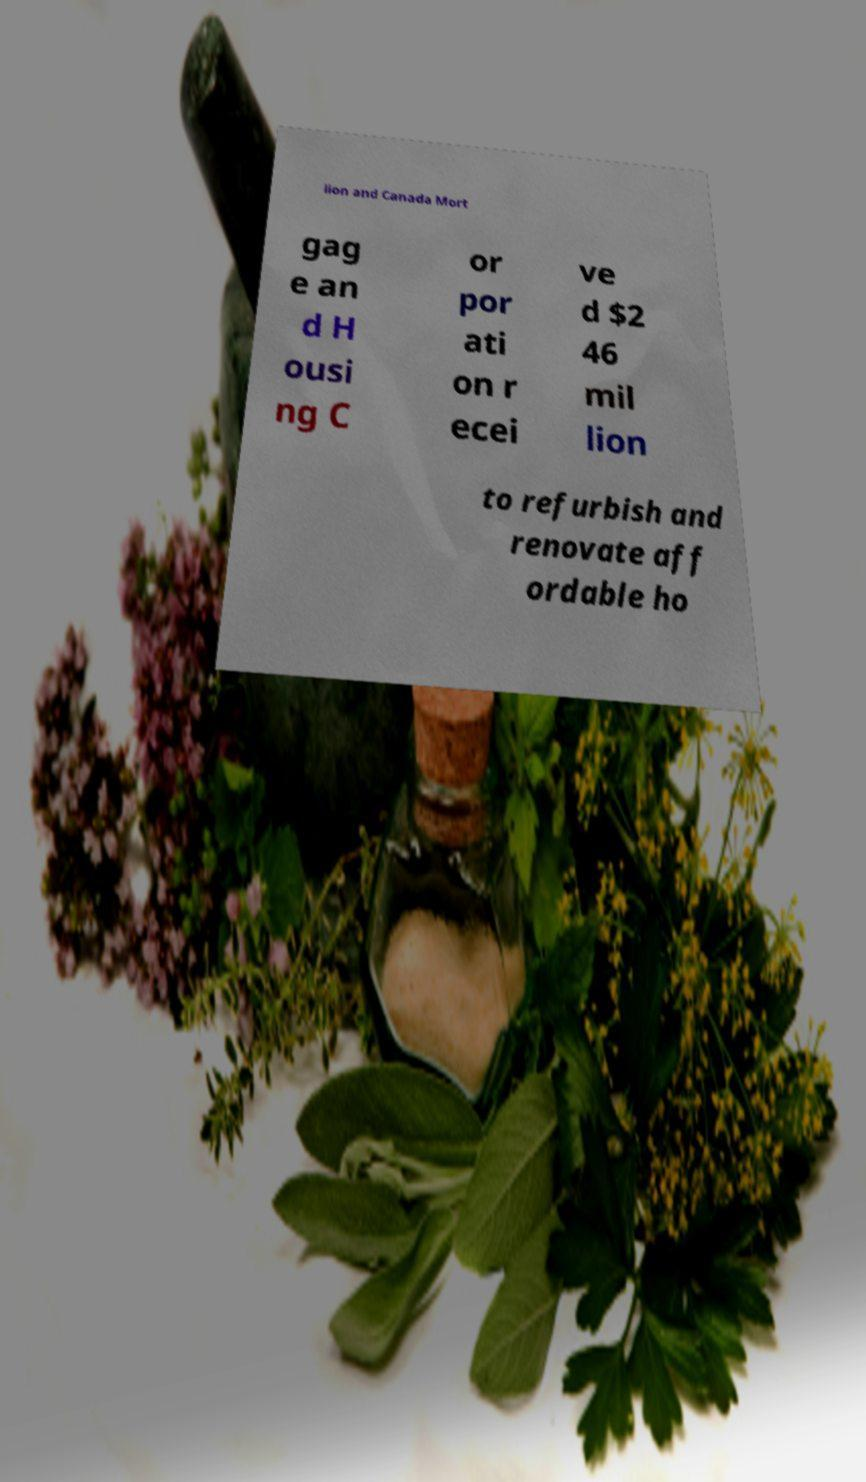Can you accurately transcribe the text from the provided image for me? lion and Canada Mort gag e an d H ousi ng C or por ati on r ecei ve d $2 46 mil lion to refurbish and renovate aff ordable ho 